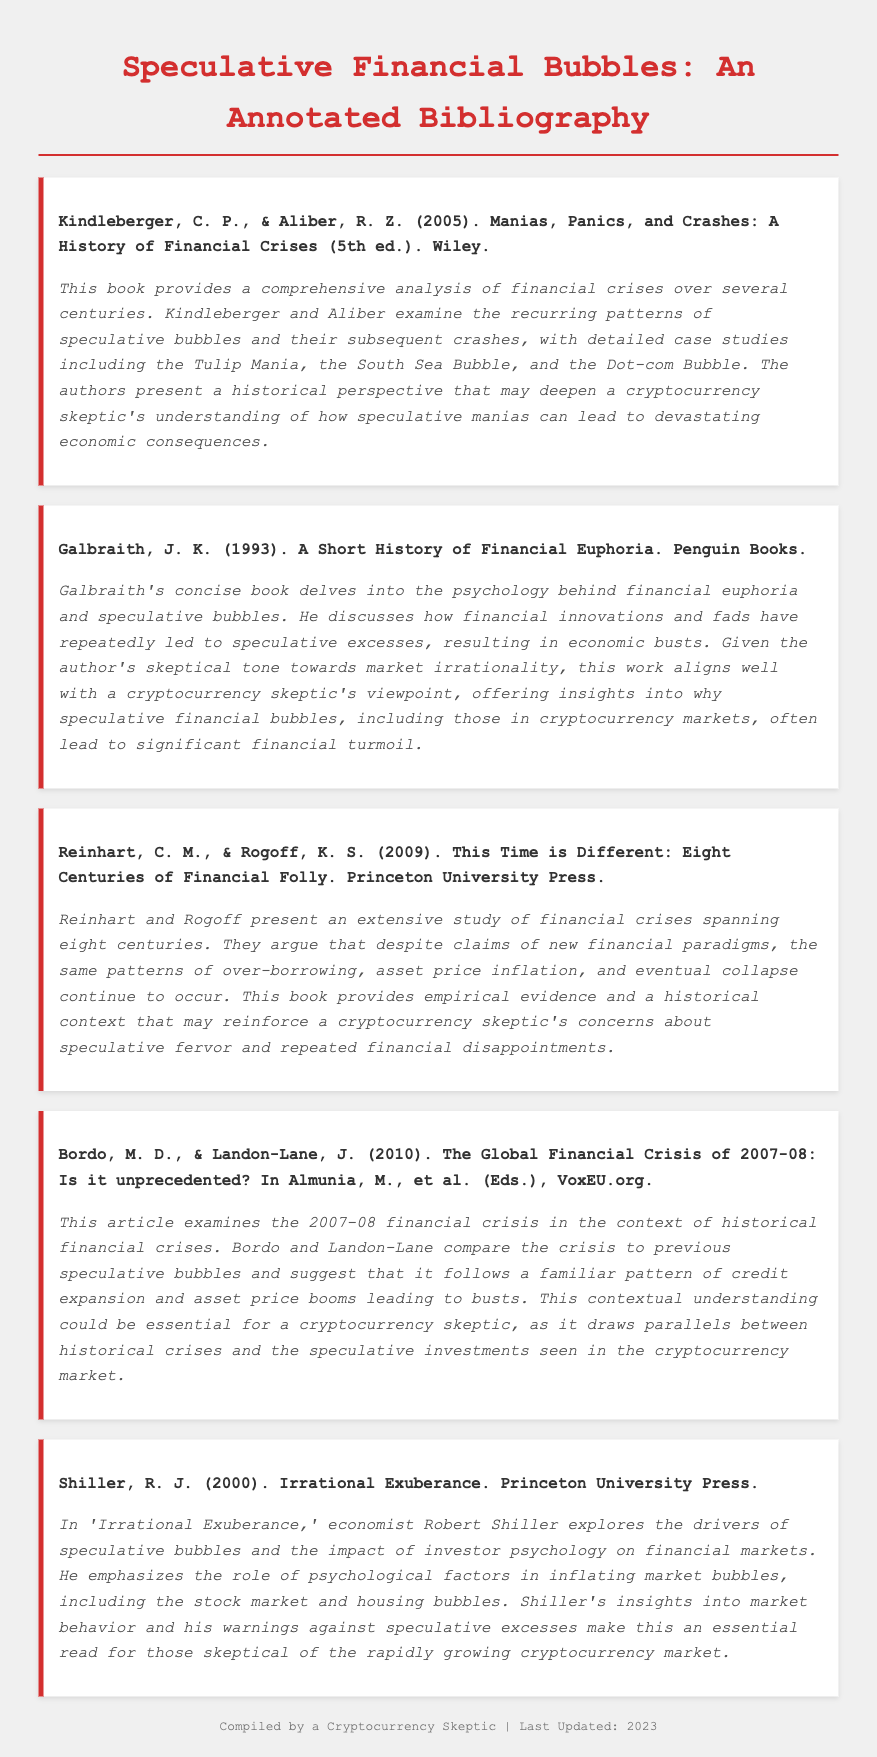what is the title of the bibliography? The title of the bibliography is presented at the top of the document.
Answer: Speculative Financial Bubbles: An Annotated Bibliography who are the authors of the first entry? The first entry includes the authors listed immediately after the title in the citation.
Answer: Kindleberger, C. P., & Aliber, R. Z what year was "A Short History of Financial Euphoria" published? The publication year is stated next to the author's name in the citation of the second entry.
Answer: 1993 what is the primary focus of Shiller's book? The annotation for Shiller's book gives insight into its primary focus.
Answer: Speculative bubbles how many centuries of financial crises are covered in Reinhart and Rogoff's book? The title specifies the coverage in terms of centuries as mentioned in the citation.
Answer: Eight which financial crisis is analyzed in the article by Bordo and Landon-Lane? The annotation describes the specific financial crisis that is the subject of the second-to-last entry.
Answer: 2007-08 financial crisis what is the format of the bibliography entries? The entries follow a specific structure usually seen in annotated bibliographies with citations followed by annotations.
Answer: Citation and annotation how many entries are included in this bibliography? The total number of entries can be counted from the document.
Answer: Five 